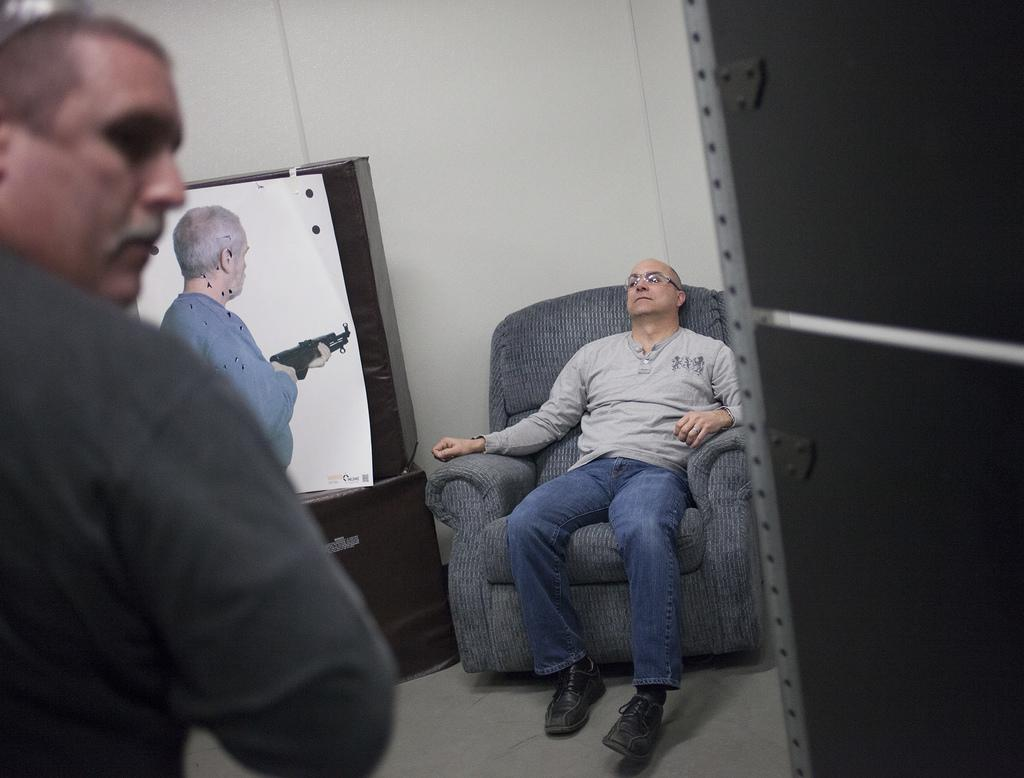What is the man in the image doing? There is a man sitting on a couch in the image. How many men are standing in the image? There are two men standing on the left side of the image. What is one of the standing men holding? One of the standing men is holding a gun. What can be seen in the background of the image? There is a wall visible in the background of the image. What type of theory is being discussed by the men in the image? There is no indication in the image that the men are discussing any theories. Can you tell me how many markets are visible in the image? There are no markets present in the image. 